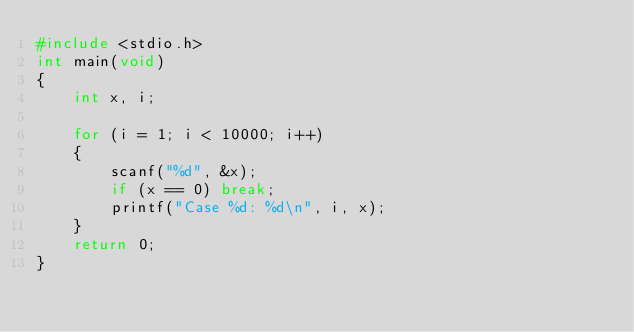<code> <loc_0><loc_0><loc_500><loc_500><_C_>#include <stdio.h>
int main(void)
{
	int x, i;

	for (i = 1; i < 10000; i++) 
	{
		scanf("%d", &x);
		if (x == 0) break;
		printf("Case %d: %d\n", i, x);
	}
	return 0;
}</code> 